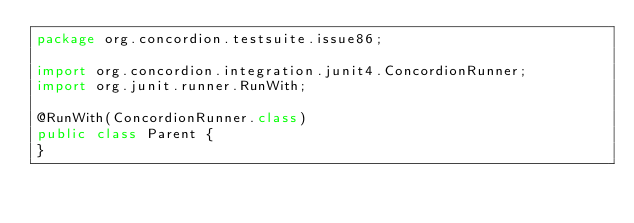<code> <loc_0><loc_0><loc_500><loc_500><_Java_>package org.concordion.testsuite.issue86;

import org.concordion.integration.junit4.ConcordionRunner;
import org.junit.runner.RunWith;

@RunWith(ConcordionRunner.class)
public class Parent {
}
</code> 